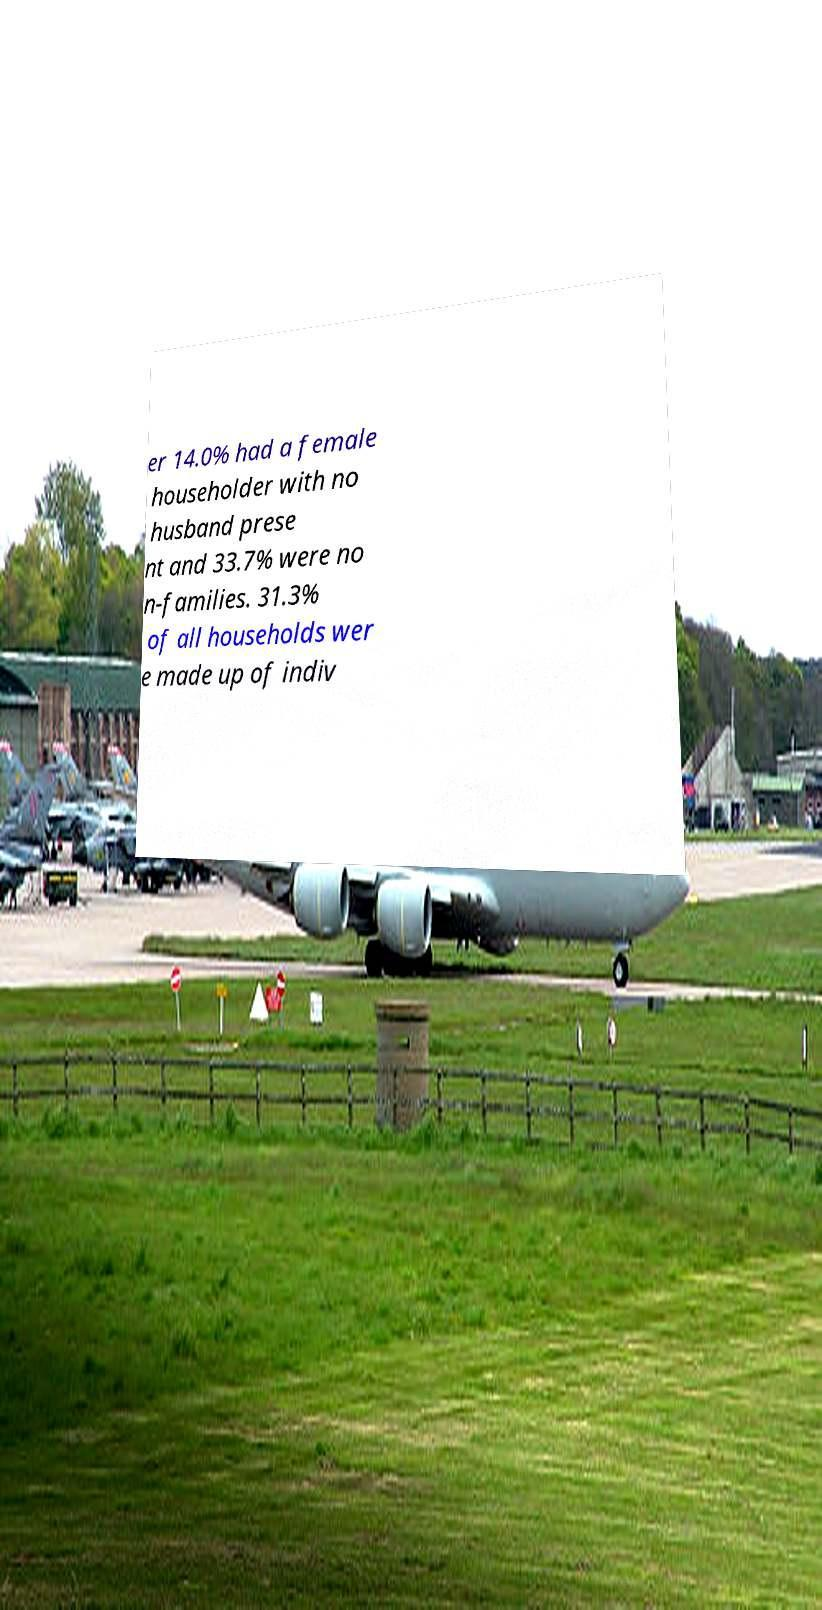I need the written content from this picture converted into text. Can you do that? er 14.0% had a female householder with no husband prese nt and 33.7% were no n-families. 31.3% of all households wer e made up of indiv 